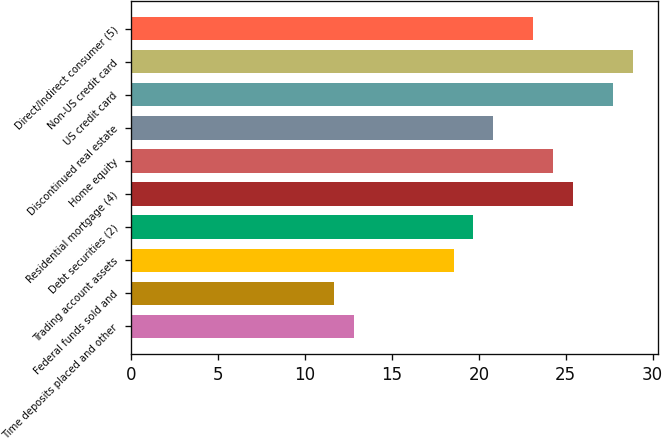Convert chart. <chart><loc_0><loc_0><loc_500><loc_500><bar_chart><fcel>Time deposits placed and other<fcel>Federal funds sold and<fcel>Trading account assets<fcel>Debt securities (2)<fcel>Residential mortgage (4)<fcel>Home equity<fcel>Discontinued real estate<fcel>US credit card<fcel>Non-US credit card<fcel>Direct/Indirect consumer (5)<nl><fcel>12.79<fcel>11.64<fcel>18.54<fcel>19.69<fcel>25.44<fcel>24.29<fcel>20.84<fcel>27.74<fcel>28.89<fcel>23.14<nl></chart> 